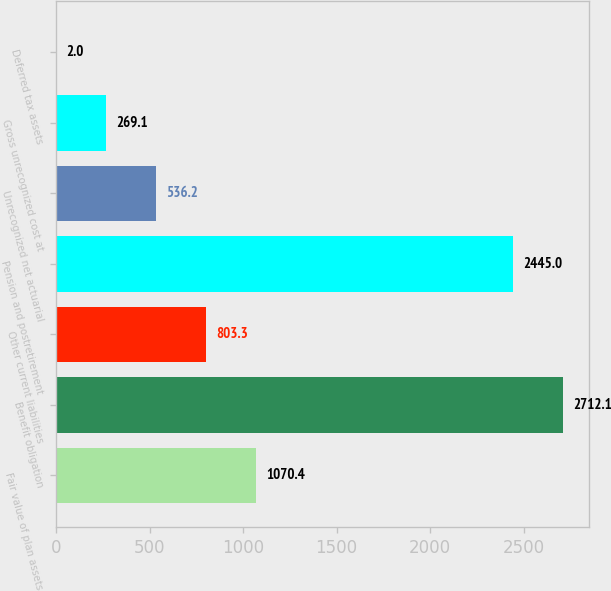Convert chart. <chart><loc_0><loc_0><loc_500><loc_500><bar_chart><fcel>Fair value of plan assets<fcel>Benefit obligation<fcel>Other current liabilities<fcel>Pension and postretirement<fcel>Unrecognized net actuarial<fcel>Gross unrecognized cost at<fcel>Deferred tax assets<nl><fcel>1070.4<fcel>2712.1<fcel>803.3<fcel>2445<fcel>536.2<fcel>269.1<fcel>2<nl></chart> 